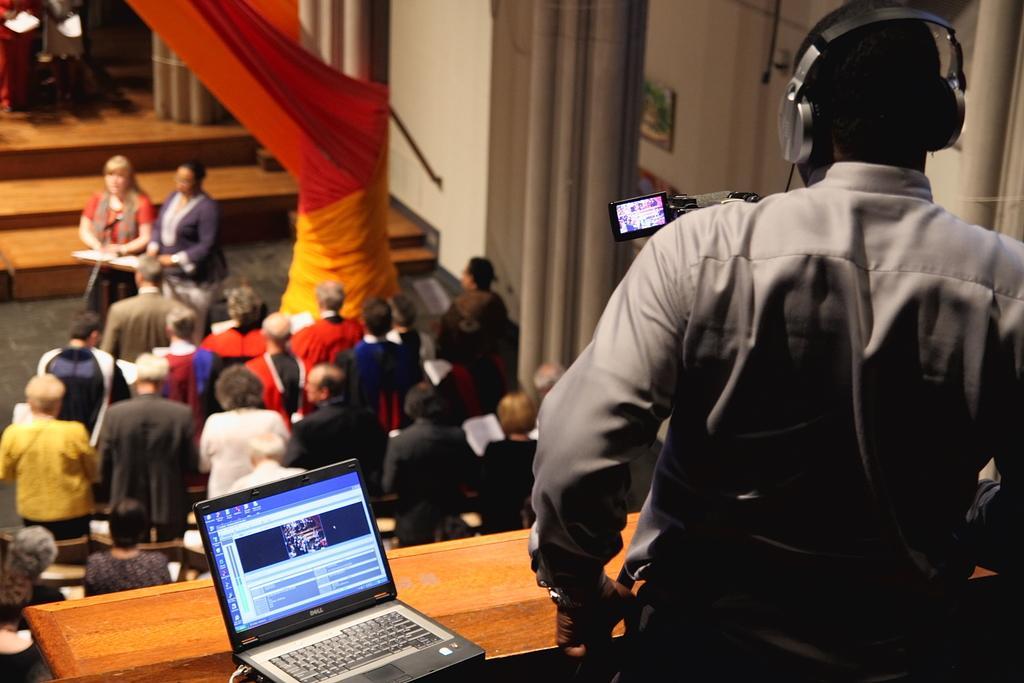How would you summarize this image in a sentence or two? In the center of the image we can see a group of people are standing and holding the books. On the left side of the image we can see two people are standing, in-front of them we can see a table. On the table we can see a boom, mic with stand. At the bottom of the image we can see a table. On the table we can see a laptop. On the right side of the image we can see a man is standing and wearing headset, in-front of him we can see a camera with stand. In the background of the image we can see the wall, pillars, boards, stairs, lights, cloth and floor. 